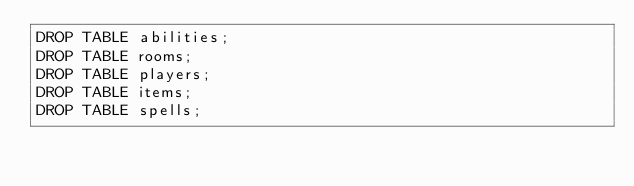<code> <loc_0><loc_0><loc_500><loc_500><_SQL_>DROP TABLE abilities;
DROP TABLE rooms;
DROP TABLE players;
DROP TABLE items;
DROP TABLE spells;
</code> 